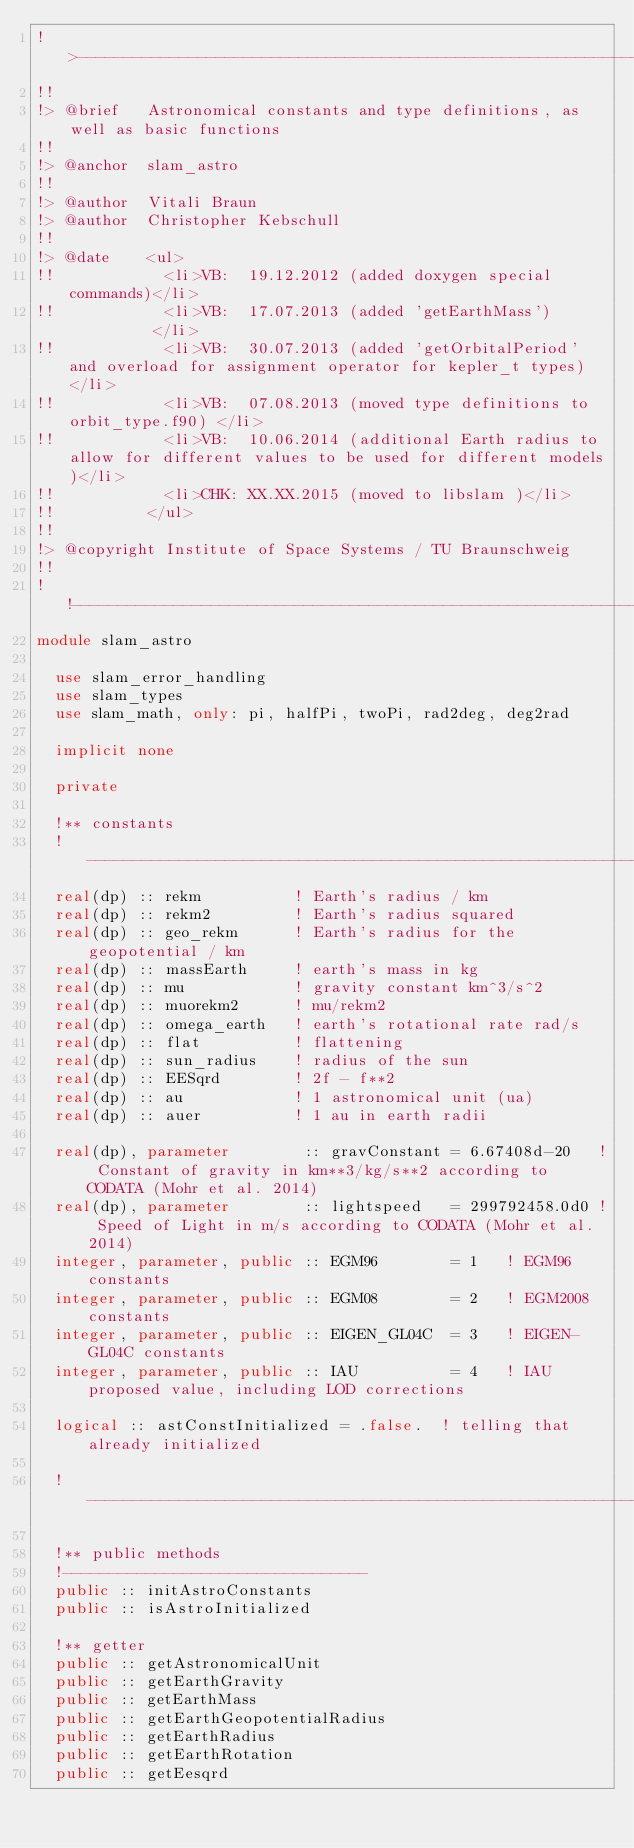Convert code to text. <code><loc_0><loc_0><loc_500><loc_500><_FORTRAN_>!>------------------------------------------------------------------------------------
!!
!> @brief   Astronomical constants and type definitions, as well as basic functions
!!
!> @anchor  slam_astro
!!
!> @author  Vitali Braun
!> @author  Christopher Kebschull
!!
!> @date    <ul>
!!            <li>VB:  19.12.2012 (added doxygen special commands)</li>
!!            <li>VB:  17.07.2013 (added 'getEarthMass')          </li>
!!            <li>VB:  30.07.2013 (added 'getOrbitalPeriod' and overload for assignment operator for kepler_t types) </li>
!!            <li>VB:  07.08.2013 (moved type definitions to orbit_type.f90) </li>
!!            <li>VB:  10.06.2014 (additional Earth radius to allow for different values to be used for different models)</li>
!!            <li>CHK: XX.XX.2015 (moved to libslam )</li>
!!          </ul>
!!
!> @copyright Institute of Space Systems / TU Braunschweig
!!
!!------------------------------------------------------------------------------------
module slam_astro

  use slam_error_handling
  use slam_types
  use slam_math, only: pi, halfPi, twoPi, rad2deg, deg2rad

  implicit none

  private

  !** constants
  !---------------------------------------------------------------
  real(dp) :: rekm          ! Earth's radius / km
  real(dp) :: rekm2         ! Earth's radius squared
  real(dp) :: geo_rekm      ! Earth's radius for the geopotential / km
  real(dp) :: massEarth     ! earth's mass in kg
  real(dp) :: mu            ! gravity constant km^3/s^2
  real(dp) :: muorekm2      ! mu/rekm2
  real(dp) :: omega_earth   ! earth's rotational rate rad/s
  real(dp) :: flat          ! flattening
  real(dp) :: sun_radius    ! radius of the sun
  real(dp) :: EESqrd        ! 2f - f**2
  real(dp) :: au            ! 1 astronomical unit (ua)
  real(dp) :: auer          ! 1 au in earth radii

  real(dp), parameter        :: gravConstant = 6.67408d-20   ! Constant of gravity in km**3/kg/s**2 according to CODATA (Mohr et al. 2014)
  real(dp), parameter        :: lightspeed   = 299792458.0d0 ! Speed of Light in m/s according to CODATA (Mohr et al. 2014)
  integer, parameter, public :: EGM96        = 1   ! EGM96 constants
  integer, parameter, public :: EGM08        = 2   ! EGM2008 constants
  integer, parameter, public :: EIGEN_GL04C  = 3   ! EIGEN-GL04C constants
  integer, parameter, public :: IAU          = 4   ! IAU proposed value, including LOD corrections

  logical :: astConstInitialized = .false.  ! telling that already initialized

  !-----------------------------------------------------------------

  !** public methods
  !---------------------------------
  public :: initAstroConstants
  public :: isAstroInitialized

  !** getter
  public :: getAstronomicalUnit
  public :: getEarthGravity
  public :: getEarthMass
  public :: getEarthGeopotentialRadius
  public :: getEarthRadius
  public :: getEarthRotation
  public :: getEesqrd</code> 